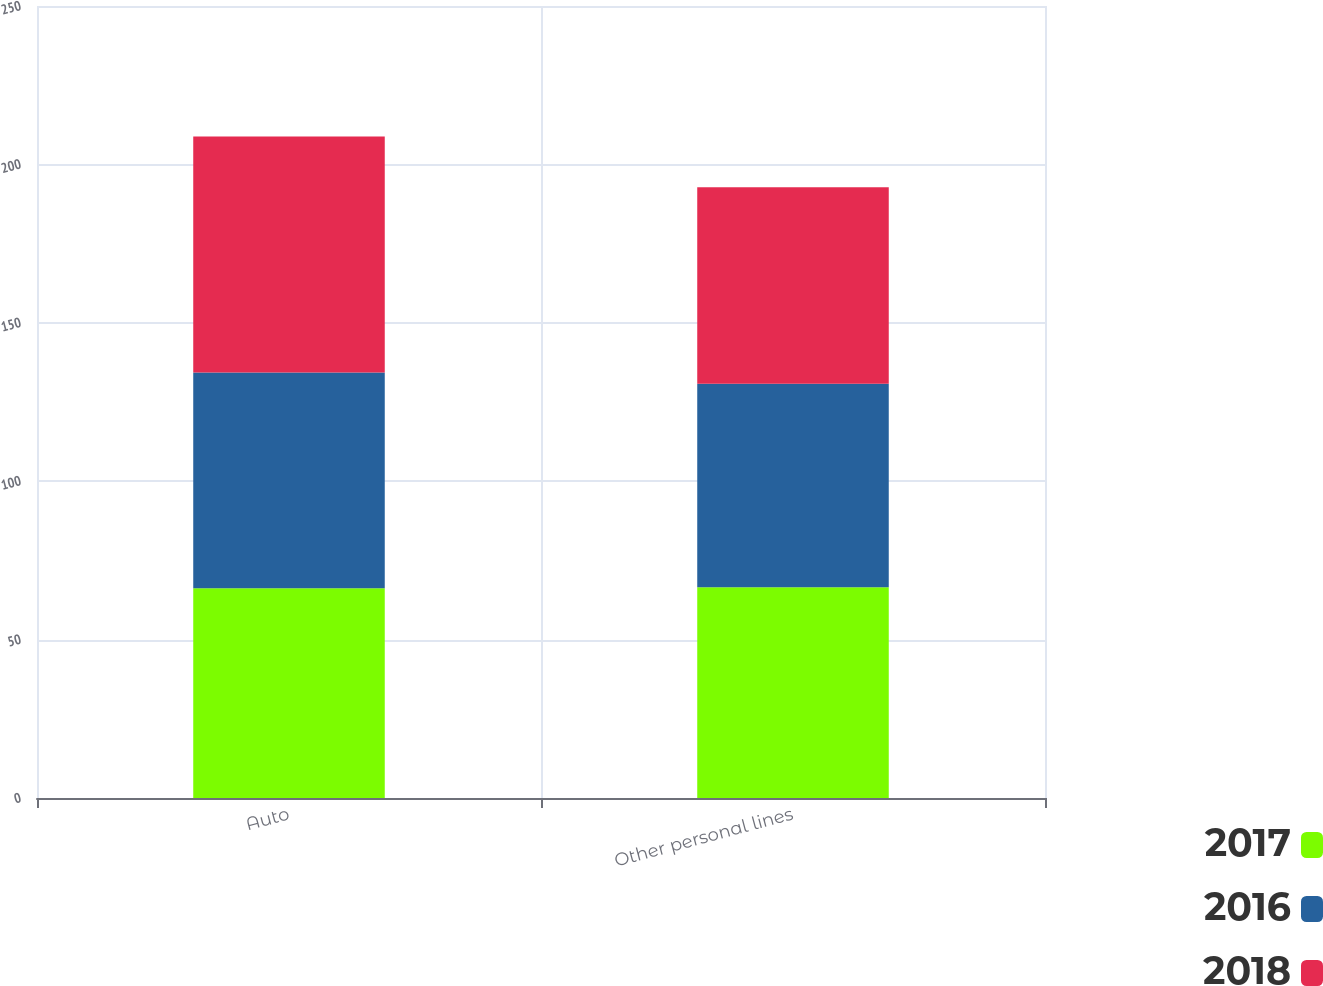<chart> <loc_0><loc_0><loc_500><loc_500><stacked_bar_chart><ecel><fcel>Auto<fcel>Other personal lines<nl><fcel>2017<fcel>66.2<fcel>66.5<nl><fcel>2016<fcel>68.1<fcel>64.3<nl><fcel>2018<fcel>74.5<fcel>62<nl></chart> 